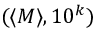Convert formula to latex. <formula><loc_0><loc_0><loc_500><loc_500>( \langle M \rangle , 1 0 ^ { k } )</formula> 